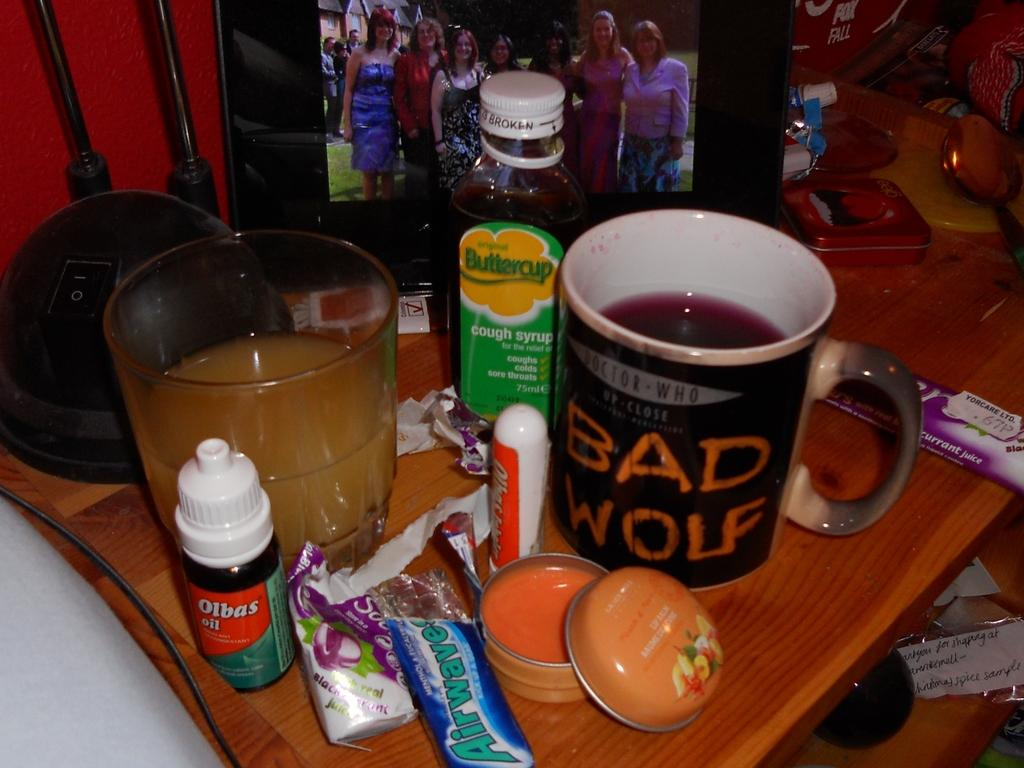Provide a one-sentence caption for the provided image. To the left of the Bad Wolf mug is a bottle of Buttercup cough syrup. 